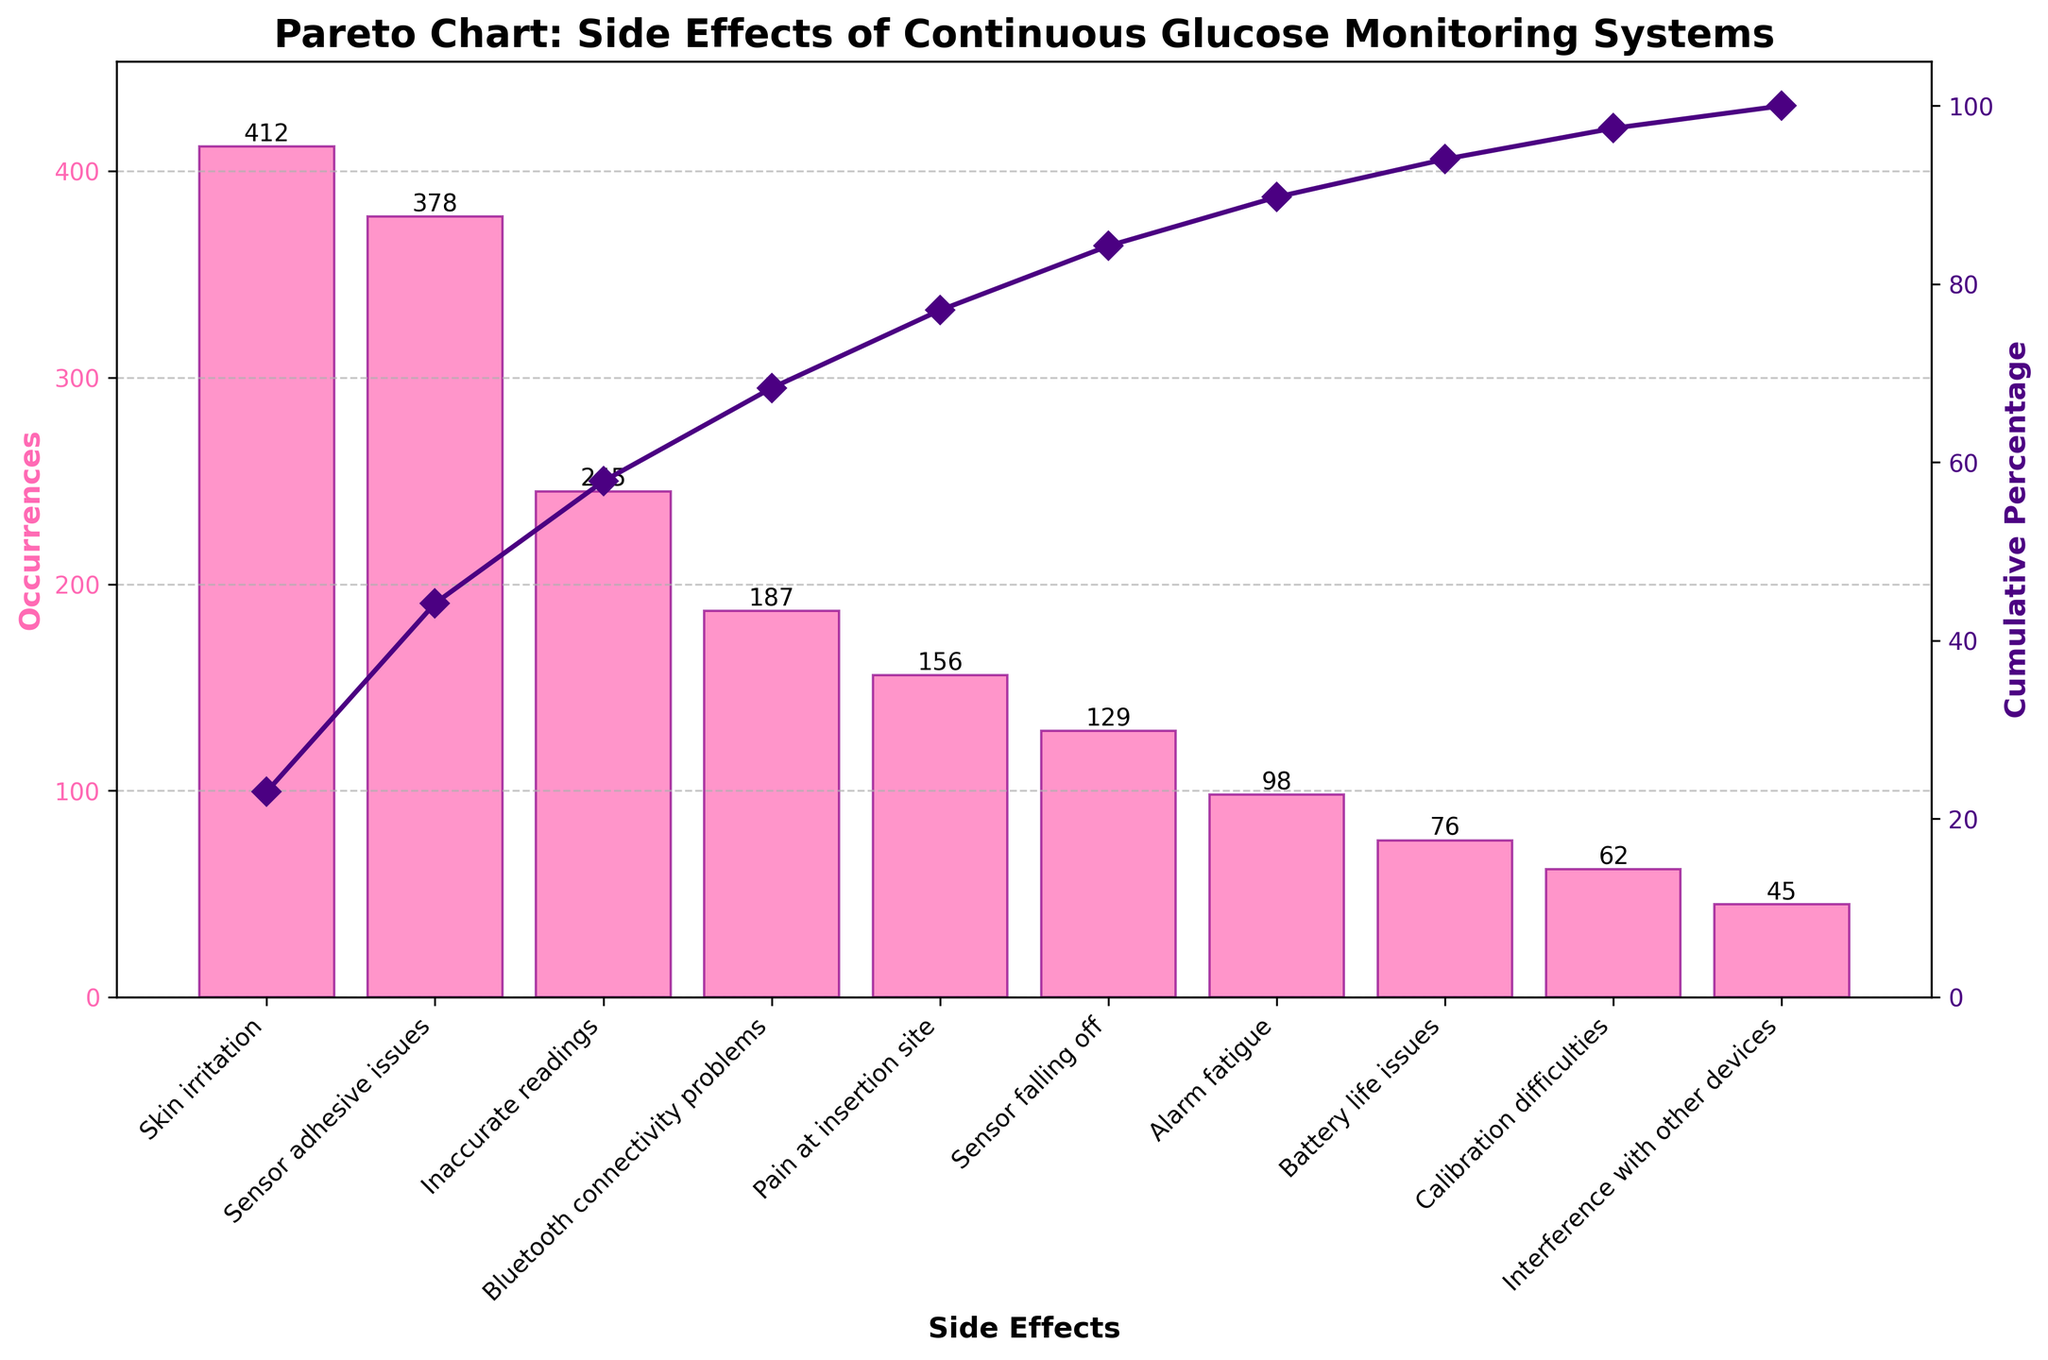What is the title of the figure? The title is usually found at the top of the figure. In this case, it reads: 'Pareto Chart: Side Effects of Continuous Glucose Monitoring Systems'.
Answer: Pareto Chart: Side Effects of Continuous Glucose Monitoring Systems What side effect has the highest number of occurrences? The tallest bar on the chart represents the side effect with the highest number of occurrences. The bar labeled 'Skin irritation' is the tallest.
Answer: Skin irritation How many occurrences were reported for 'Inaccurate readings'? Find the bar labeled 'Inaccurate readings' and look at the top of this bar where the value is listed. The value is 245.
Answer: 245 What's the cumulative percentage for 'Sensor adhesive issues'? Locate 'Sensor adhesive issues' on the x-axis, follow it up to the line representing cumulative percentage, and read the corresponding y-axis value. It is slightly above 50%.
Answer: Around 50% What are the three most common side effects? Look at the three tallest bars as they represent the most common side effects. They are 'Skin irritation', 'Sensor adhesive issues', and 'Inaccurate readings'.
Answer: Skin irritation, Sensor adhesive issues, Inaccurate readings Which side effect has fewer occurrences, 'Bluetooth connectivity problems' or 'Pain at insertion site'? Compare the height of the bars labeled 'Bluetooth connectivity problems' and 'Pain at insertion site'. The bar for 'Bluetooth connectivity problems' is higher.
Answer: Pain at insertion site What is the cumulative percentage at 'Alarm fatigue'? Locate the bar for 'Alarm fatigue' and follow it up to the cumulative percentage line to read the corresponding y-axis value, which is slightly above 90%.
Answer: Around 90% How many side effects have more than 200 occurrences? Count the bars that have numerical labels greater than 200. There are three such bars: 'Skin irritation', 'Sensor adhesive issues', and 'Inaccurate readings'.
Answer: 3 Do 'Battery life issues' have more occurrences than 'Interference with other devices'? Compare the heights and labels of the bars. 'Battery life issues' has 76 occurrences, while 'Interference with other devices' has 45.
Answer: Yes What is the least common side effect reported? The shortest bar represents the least common side effect. The bar labeled 'Interference with other devices' is the shortest.
Answer: Interference with other devices 